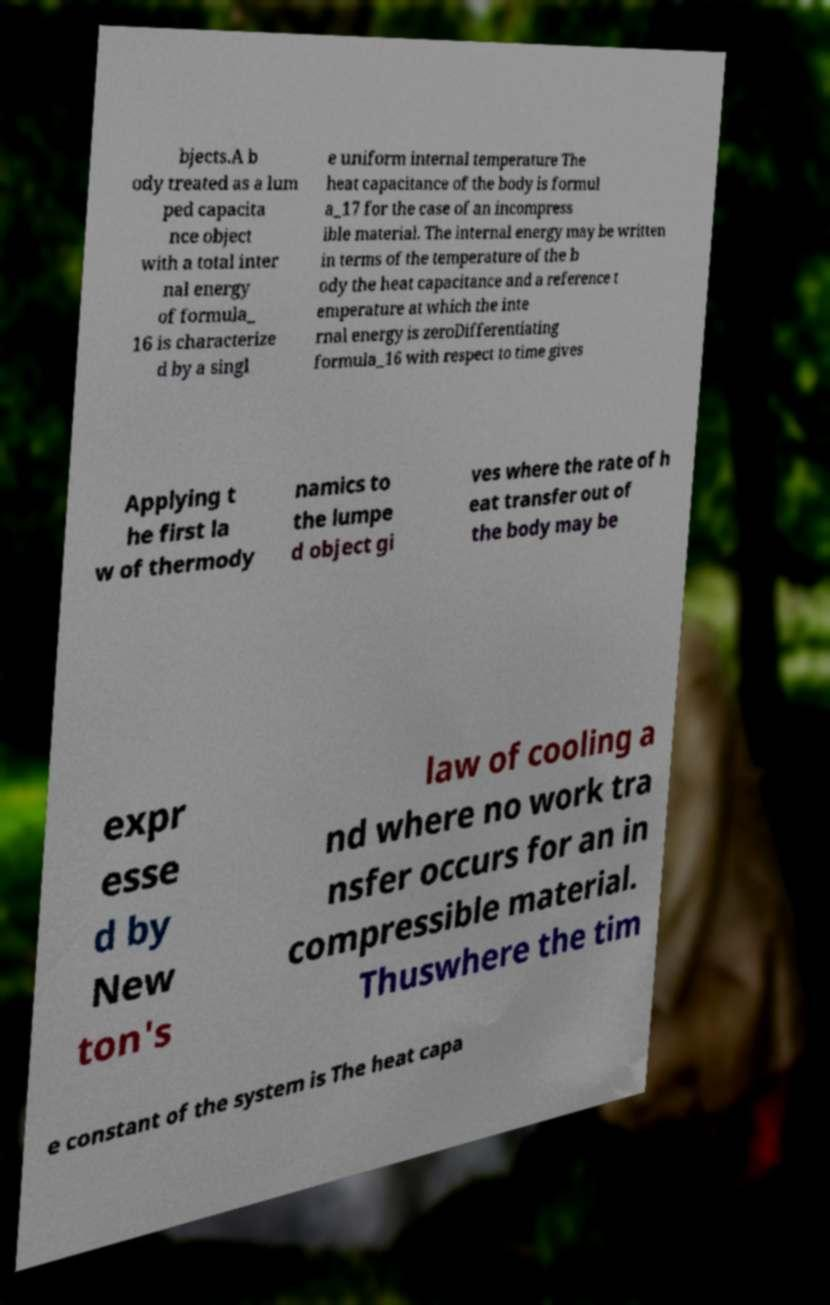What messages or text are displayed in this image? I need them in a readable, typed format. bjects.A b ody treated as a lum ped capacita nce object with a total inter nal energy of formula_ 16 is characterize d by a singl e uniform internal temperature The heat capacitance of the body is formul a_17 for the case of an incompress ible material. The internal energy may be written in terms of the temperature of the b ody the heat capacitance and a reference t emperature at which the inte rnal energy is zeroDifferentiating formula_16 with respect to time gives Applying t he first la w of thermody namics to the lumpe d object gi ves where the rate of h eat transfer out of the body may be expr esse d by New ton's law of cooling a nd where no work tra nsfer occurs for an in compressible material. Thuswhere the tim e constant of the system is The heat capa 